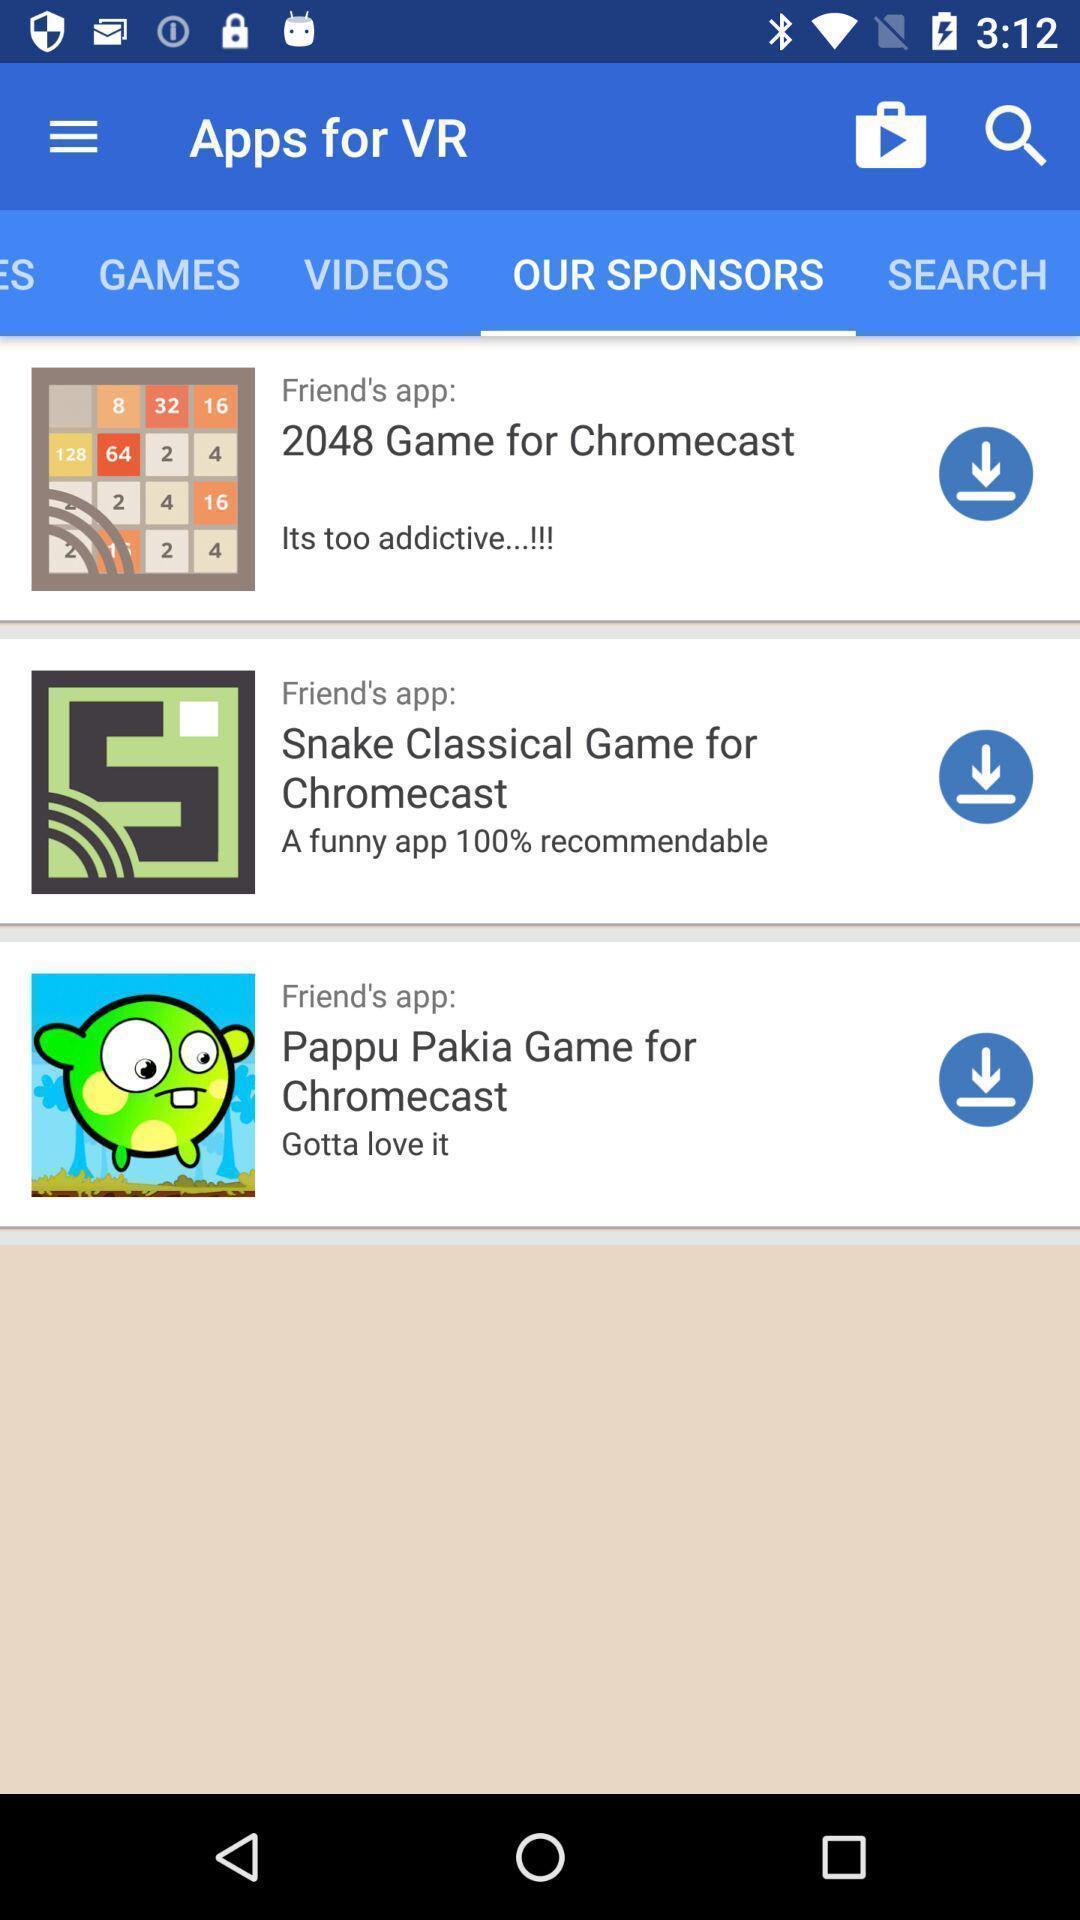What is the overall content of this screenshot? Screen displaying list of apps. 